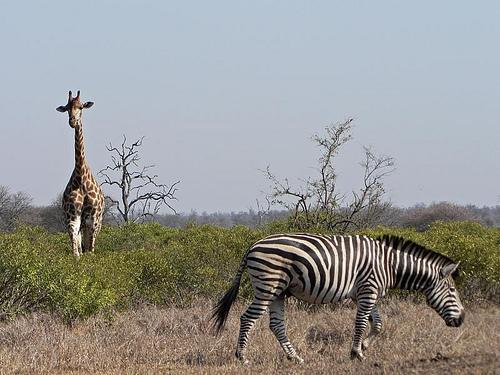How many types of animal are in the picture?
Give a very brief answer. 2. How many candles on the cake are not lit?
Give a very brief answer. 0. 